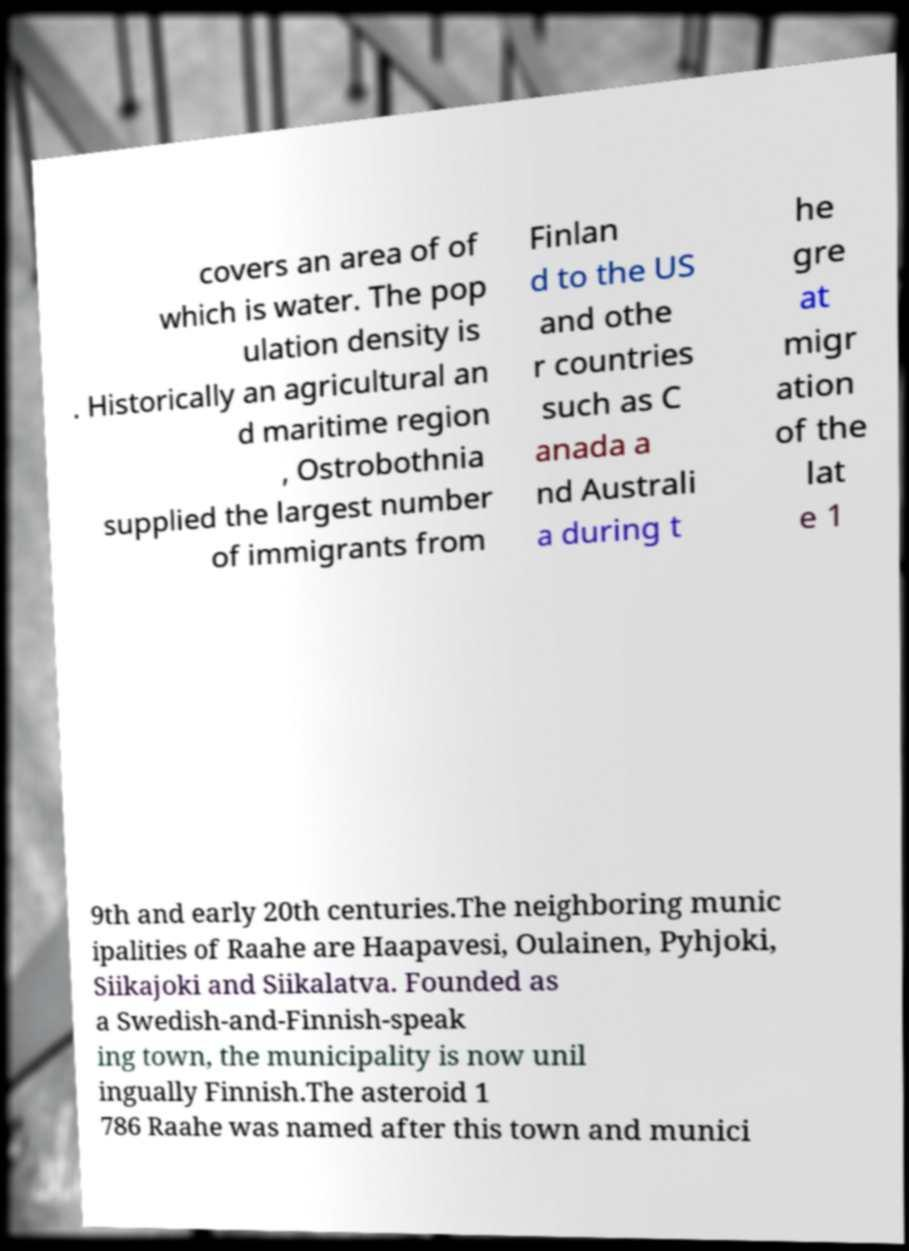For documentation purposes, I need the text within this image transcribed. Could you provide that? covers an area of of which is water. The pop ulation density is . Historically an agricultural an d maritime region , Ostrobothnia supplied the largest number of immigrants from Finlan d to the US and othe r countries such as C anada a nd Australi a during t he gre at migr ation of the lat e 1 9th and early 20th centuries.The neighboring munic ipalities of Raahe are Haapavesi, Oulainen, Pyhjoki, Siikajoki and Siikalatva. Founded as a Swedish-and-Finnish-speak ing town, the municipality is now unil ingually Finnish.The asteroid 1 786 Raahe was named after this town and munici 